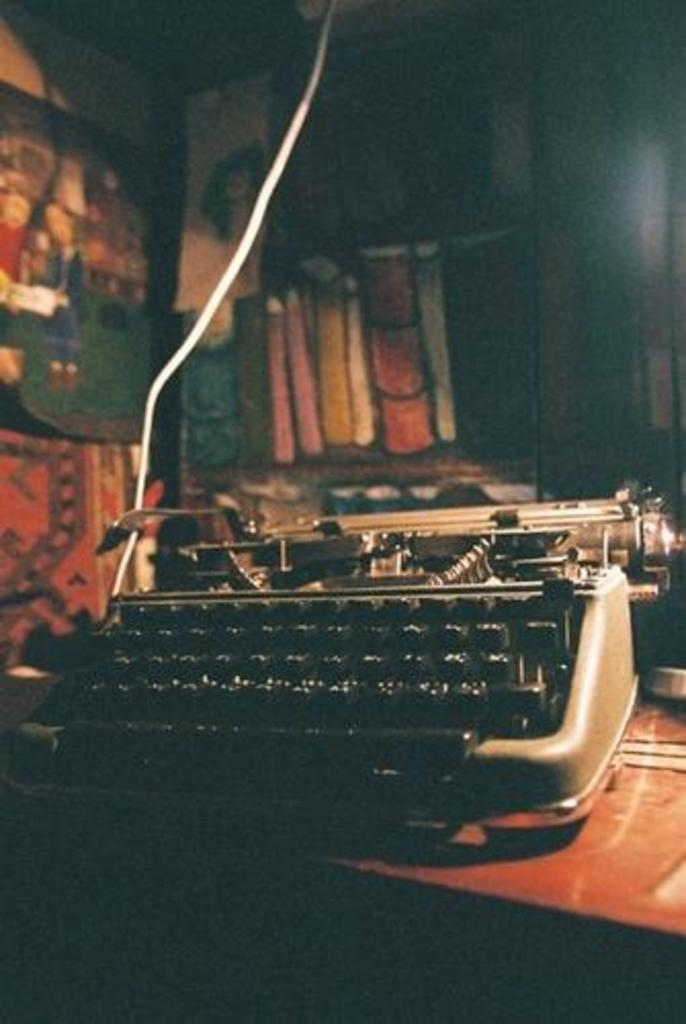What is the main object in the image? There is a typewriter in the image. Where is the typewriter located? The typewriter is on a surface. What can be seen in the background of the image? There are objects visible in the background of the image. What class is the typewriter attending in the image? There is no indication in the image that the typewriter is attending a class, as it is an inanimate object. 